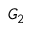<formula> <loc_0><loc_0><loc_500><loc_500>G _ { 2 }</formula> 